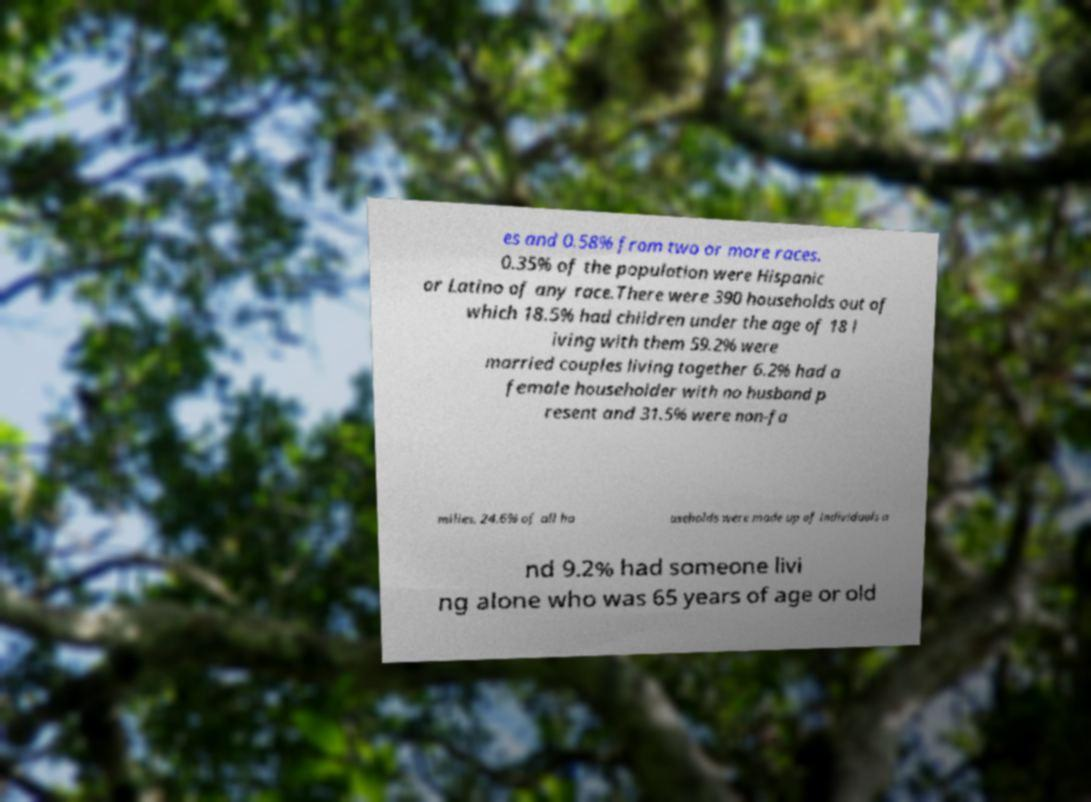Please read and relay the text visible in this image. What does it say? es and 0.58% from two or more races. 0.35% of the population were Hispanic or Latino of any race.There were 390 households out of which 18.5% had children under the age of 18 l iving with them 59.2% were married couples living together 6.2% had a female householder with no husband p resent and 31.5% were non-fa milies. 24.6% of all ho useholds were made up of individuals a nd 9.2% had someone livi ng alone who was 65 years of age or old 